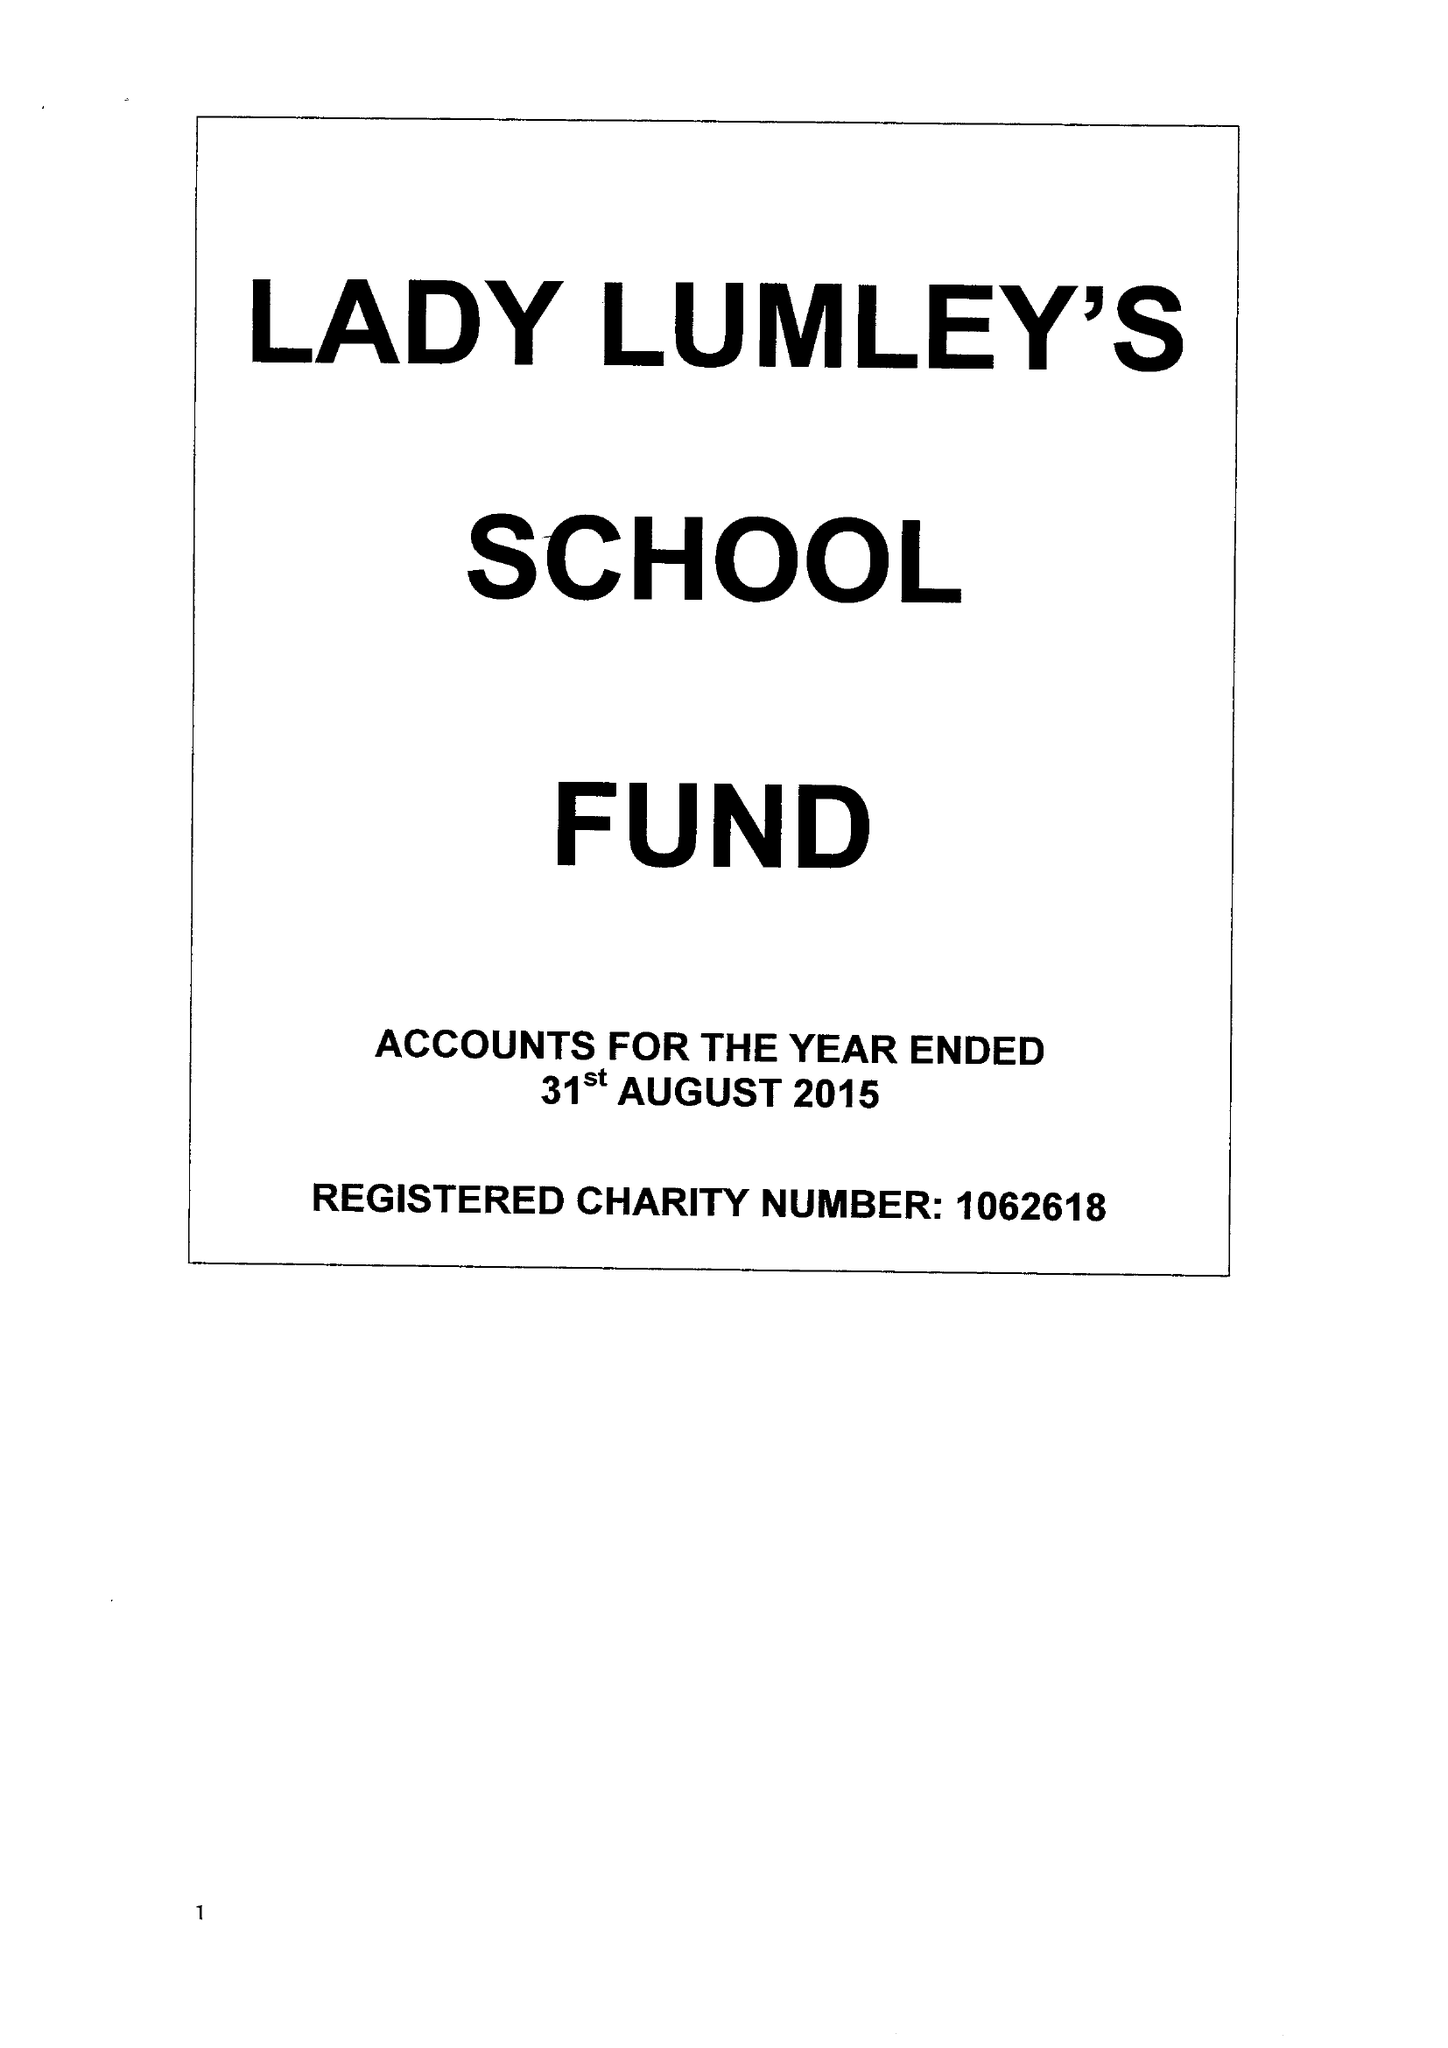What is the value for the report_date?
Answer the question using a single word or phrase. 2015-08-31 